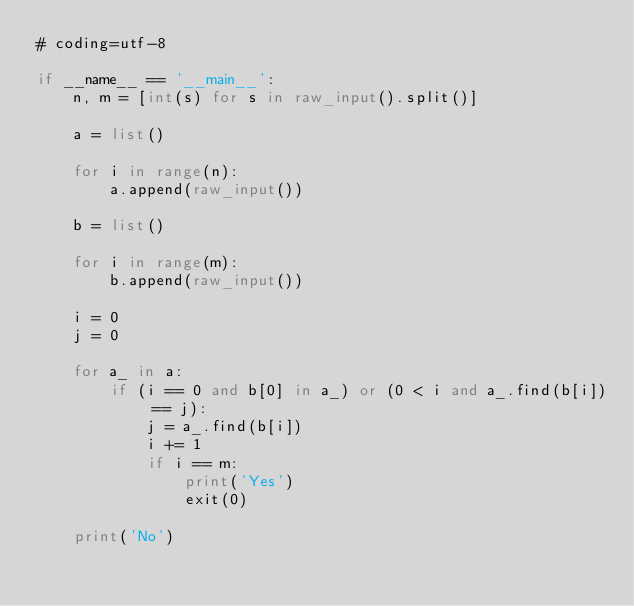<code> <loc_0><loc_0><loc_500><loc_500><_Python_># coding=utf-8

if __name__ == '__main__':
    n, m = [int(s) for s in raw_input().split()]

    a = list()

    for i in range(n):
        a.append(raw_input())

    b = list()

    for i in range(m):
        b.append(raw_input())

    i = 0
    j = 0

    for a_ in a:
        if (i == 0 and b[0] in a_) or (0 < i and a_.find(b[i]) == j):
            j = a_.find(b[i])
            i += 1
            if i == m:
                print('Yes')
                exit(0)

    print('No')
</code> 